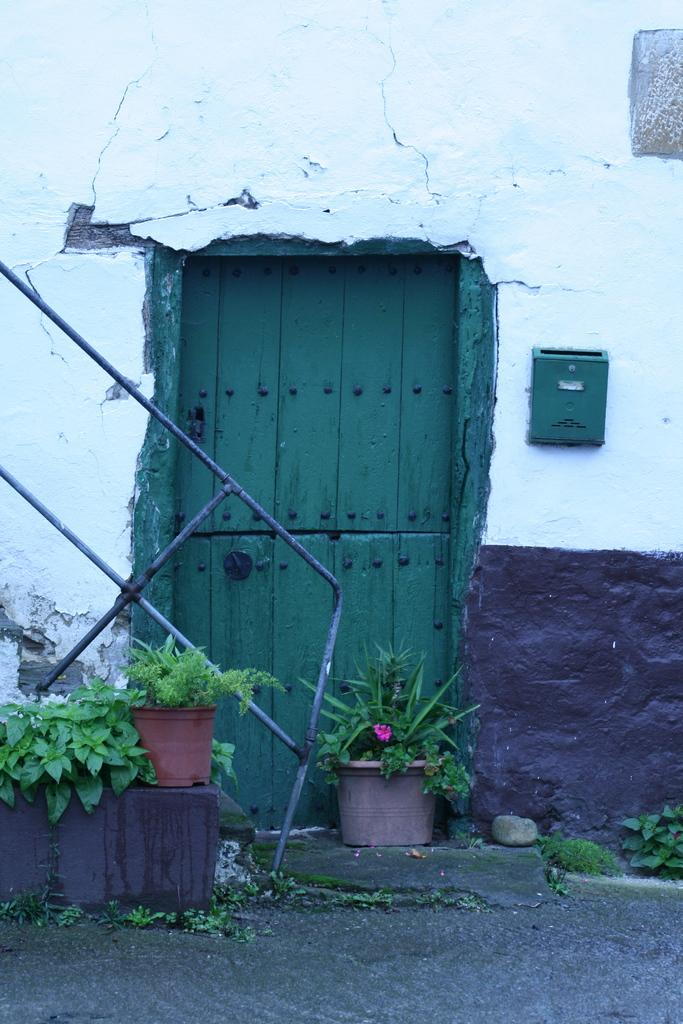What is present on the wall in the image? There is a door on a wall in the image. What is the purpose of the door? The door is likely for entering or exiting a room or space. What can be seen in front of the door? There are plant pots in front of the door. What type of wine is being served in the image? There is no wine present in the image; it features a door on a wall with plant pots in front of it. What route is visible in the image? There is no route visible in the image; it only shows a door on a wall with plant pots in front of it. 